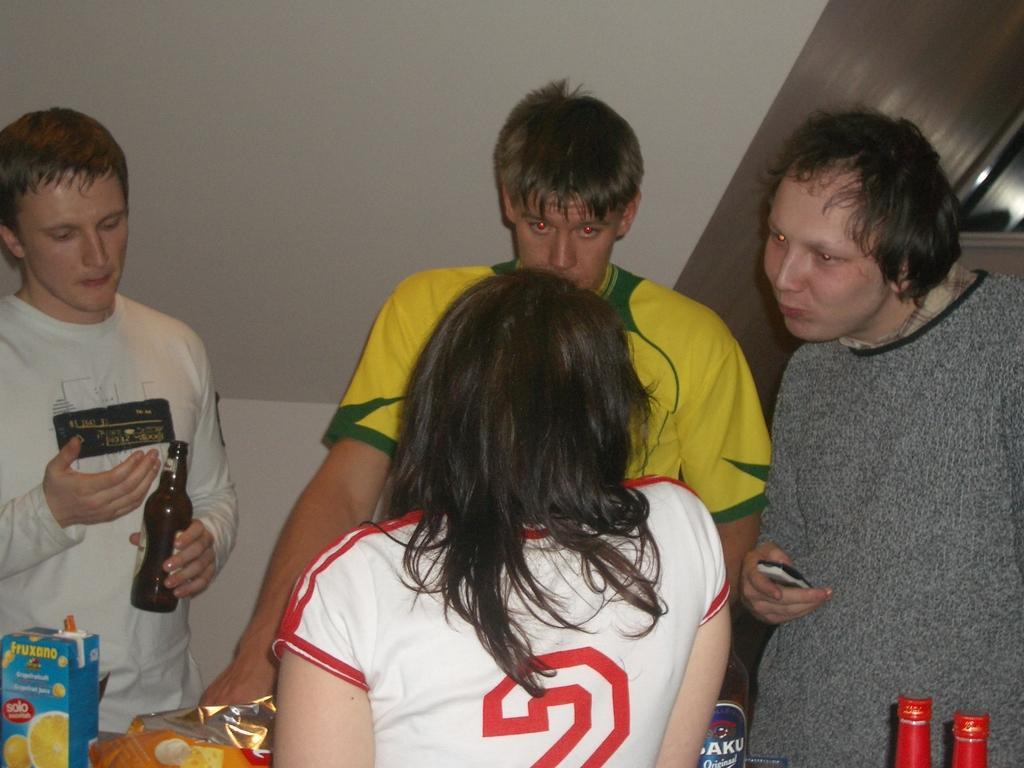In one or two sentences, can you explain what this image depicts? In this image, few peoples are standing. At the bottom , w can see some bottles, these is a sticker on it ,packets, some box. On left side, man is holding bottle on his hand. Right person is holding a mobile in his hand. Back Side we can see a white color wall. 